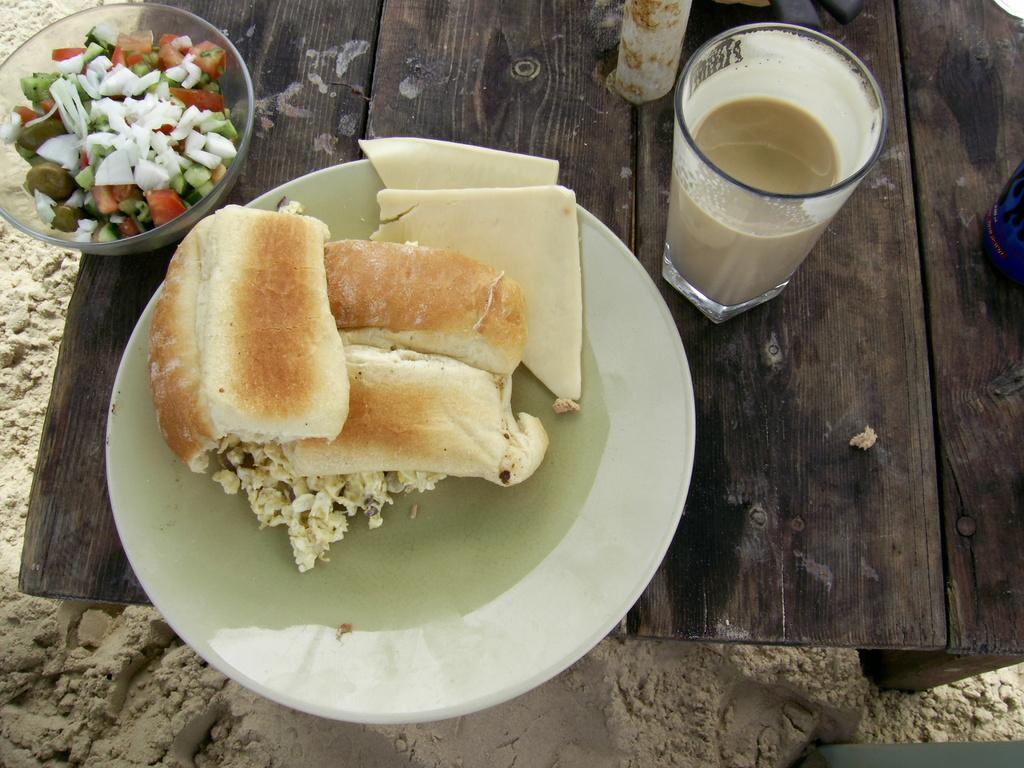What is located in the center of the image? There is a table in the center of the image. What objects are on the table? There is a plate, a bowl, and a glass on the table. What is in the plate? There are food items in the plate. What is in the bowl? There are food items in the bowl. What is in the glass? There is coffee in the glass. What type of division is being taught in the image? There is no indication of any division or educational content in the image; it primarily features a table with various objects and their contents. 